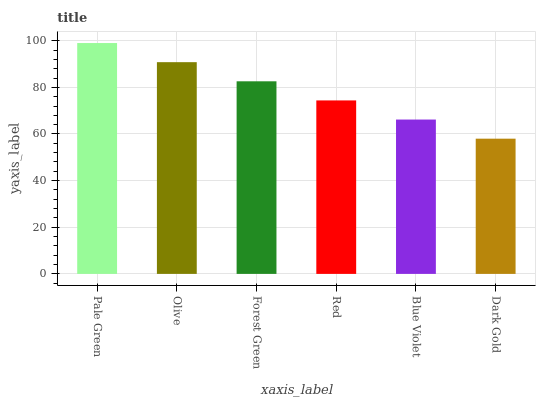Is Dark Gold the minimum?
Answer yes or no. Yes. Is Pale Green the maximum?
Answer yes or no. Yes. Is Olive the minimum?
Answer yes or no. No. Is Olive the maximum?
Answer yes or no. No. Is Pale Green greater than Olive?
Answer yes or no. Yes. Is Olive less than Pale Green?
Answer yes or no. Yes. Is Olive greater than Pale Green?
Answer yes or no. No. Is Pale Green less than Olive?
Answer yes or no. No. Is Forest Green the high median?
Answer yes or no. Yes. Is Red the low median?
Answer yes or no. Yes. Is Olive the high median?
Answer yes or no. No. Is Dark Gold the low median?
Answer yes or no. No. 